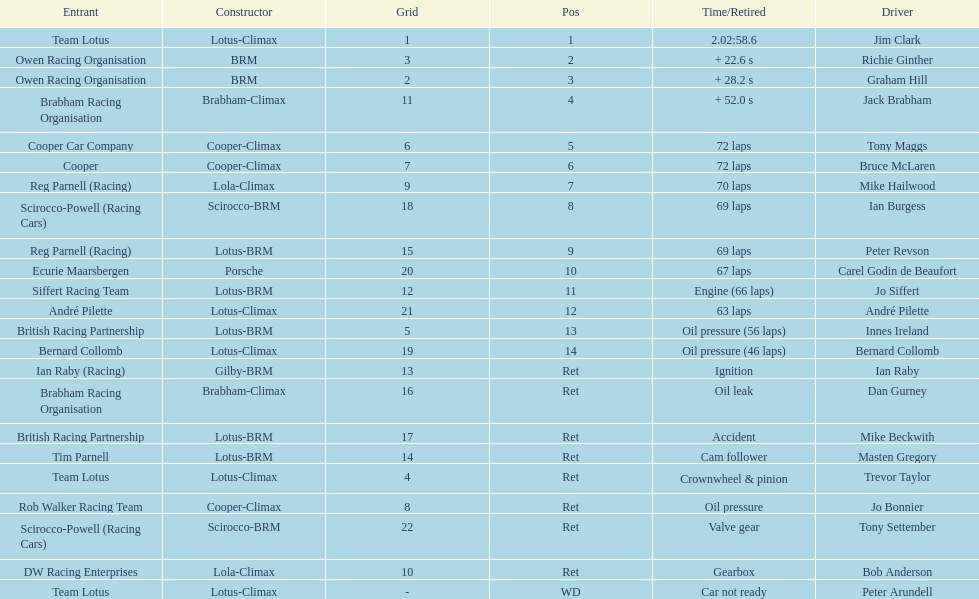Who was the top finisher that drove a cooper-climax? Tony Maggs. 